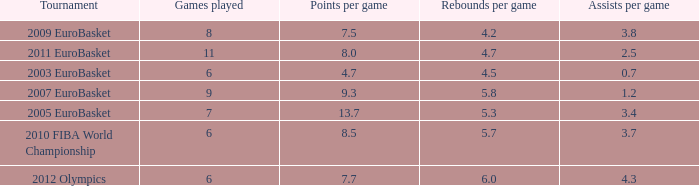How many games played have 4.7 as points per game? 6.0. 